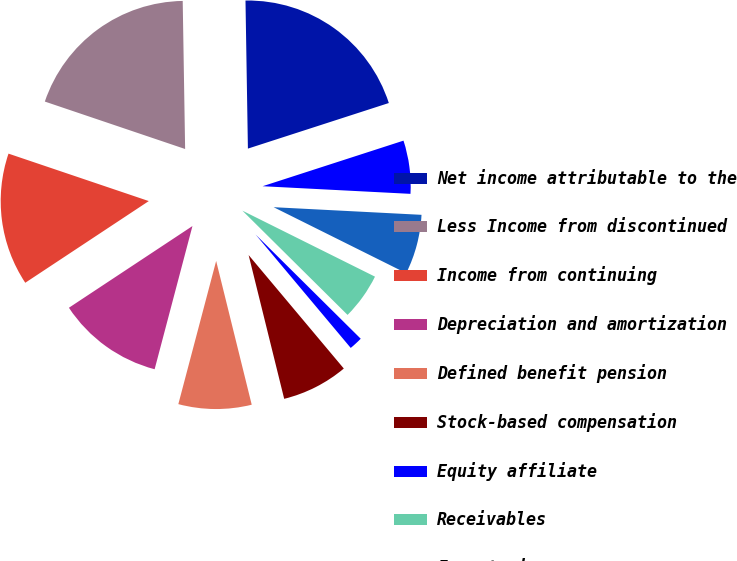Convert chart. <chart><loc_0><loc_0><loc_500><loc_500><pie_chart><fcel>Net income attributable to the<fcel>Less Income from discontinued<fcel>Income from continuing<fcel>Depreciation and amortization<fcel>Defined benefit pension<fcel>Stock-based compensation<fcel>Equity affiliate<fcel>Receivables<fcel>Inventories<fcel>Other current assets<nl><fcel>20.28%<fcel>19.55%<fcel>14.49%<fcel>11.59%<fcel>7.97%<fcel>7.25%<fcel>1.46%<fcel>5.08%<fcel>6.53%<fcel>5.8%<nl></chart> 